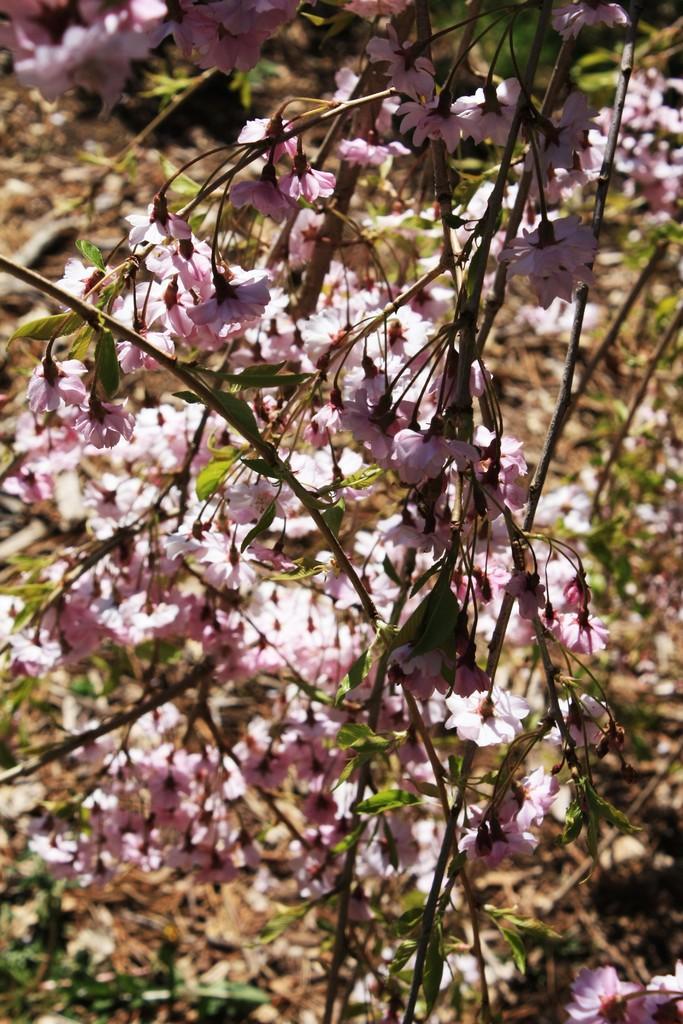Please provide a concise description of this image. In this image in the foreground there are flowers and tree, in the background there are some plants and some dry leaves. 